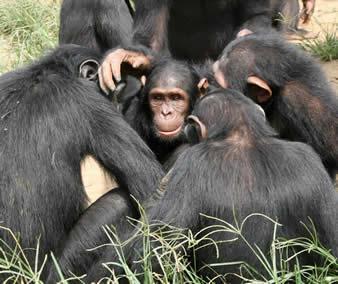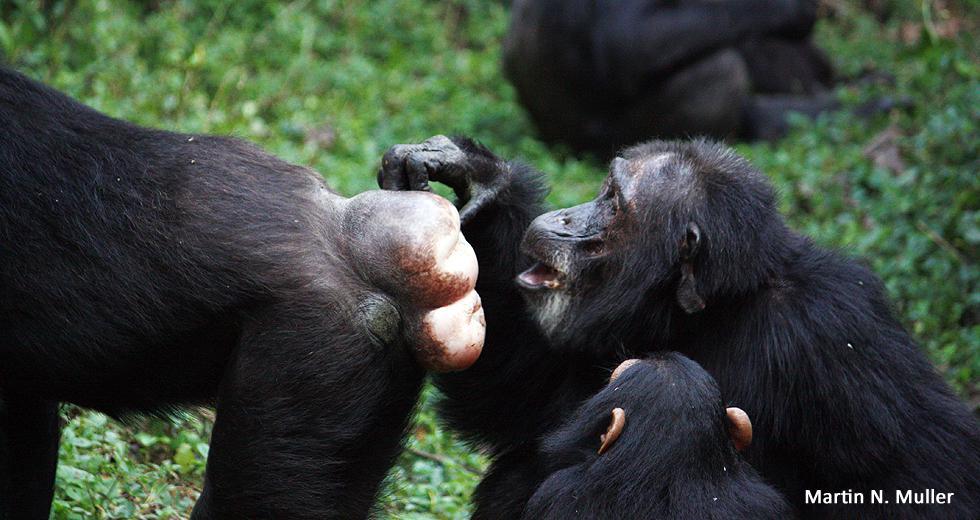The first image is the image on the left, the second image is the image on the right. Assess this claim about the two images: "An image with more than one ape shows the bulbous pinkish rear of one ape.". Correct or not? Answer yes or no. Yes. The first image is the image on the left, the second image is the image on the right. Considering the images on both sides, is "One image has a single monkey who has his mouth open, with a visible tree in the background and green grass." valid? Answer yes or no. No. 